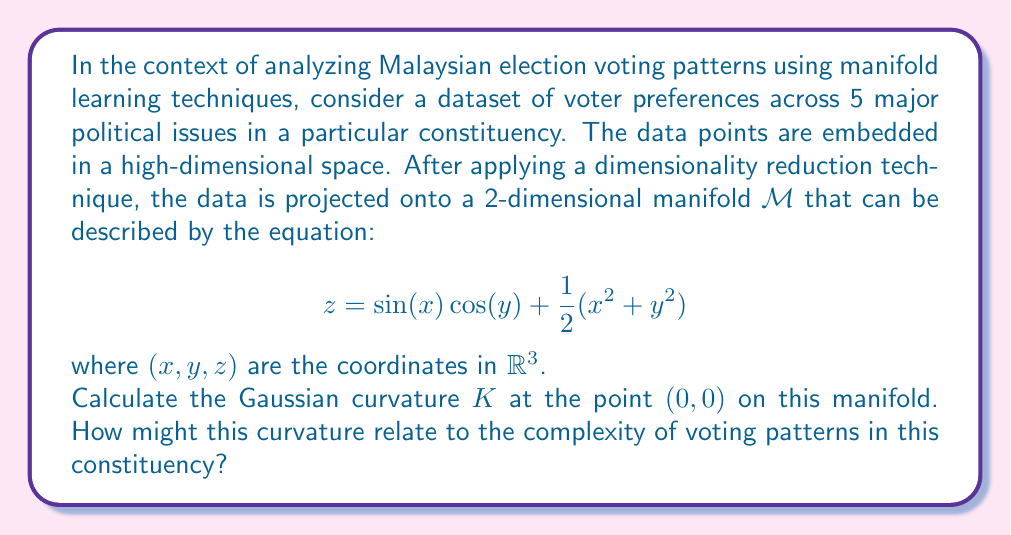What is the answer to this math problem? To solve this problem, we need to follow these steps:

1) The Gaussian curvature $K$ at a point on a surface $z = f(x,y)$ is given by:

   $$ K = \frac{f_{xx}f_{yy} - f_{xy}^2}{(1 + f_x^2 + f_y^2)^2} $$

   where subscripts denote partial derivatives.

2) Let's calculate the necessary partial derivatives:

   $f_x = \cos(x)\cos(y) + x$
   $f_y = -\sin(x)\sin(y) + y$
   $f_{xx} = -\sin(x)\cos(y) + 1$
   $f_{yy} = -\sin(x)\cos(y) + 1$
   $f_{xy} = -\cos(x)\sin(y)$

3) At the point $(0,0)$:

   $f_x(0,0) = 1$
   $f_y(0,0) = 0$
   $f_{xx}(0,0) = 1$
   $f_{yy}(0,0) = 1$
   $f_{xy}(0,0) = 0$

4) Substituting these values into the curvature formula:

   $$ K = \frac{1 \cdot 1 - 0^2}{(1 + 1^2 + 0^2)^2} = \frac{1}{4} $$

5) Interpretation: A positive Gaussian curvature at $(0,0)$ indicates that the manifold is locally shaped like a dome or a hill at this point. In the context of voting patterns, this could suggest a convergence of opinions around this point in the issue space. The magnitude of 1/4 suggests a moderate level of this convergence.

This curvature analysis can provide insights into the complexity of voting patterns:
- Areas of high positive curvature might represent issues where voters tend to agree.
- Areas of negative curvature might represent polarizing issues.
- Areas of near-zero curvature might represent issues where opinions are more uniformly distributed.

For a political observer in Malaysia, understanding these curvatures could provide valuable insights into voter behavior and potential areas of consensus or division in the electorate.
Answer: The Gaussian curvature $K$ at the point $(0,0)$ on the manifold is $\frac{1}{4}$. 